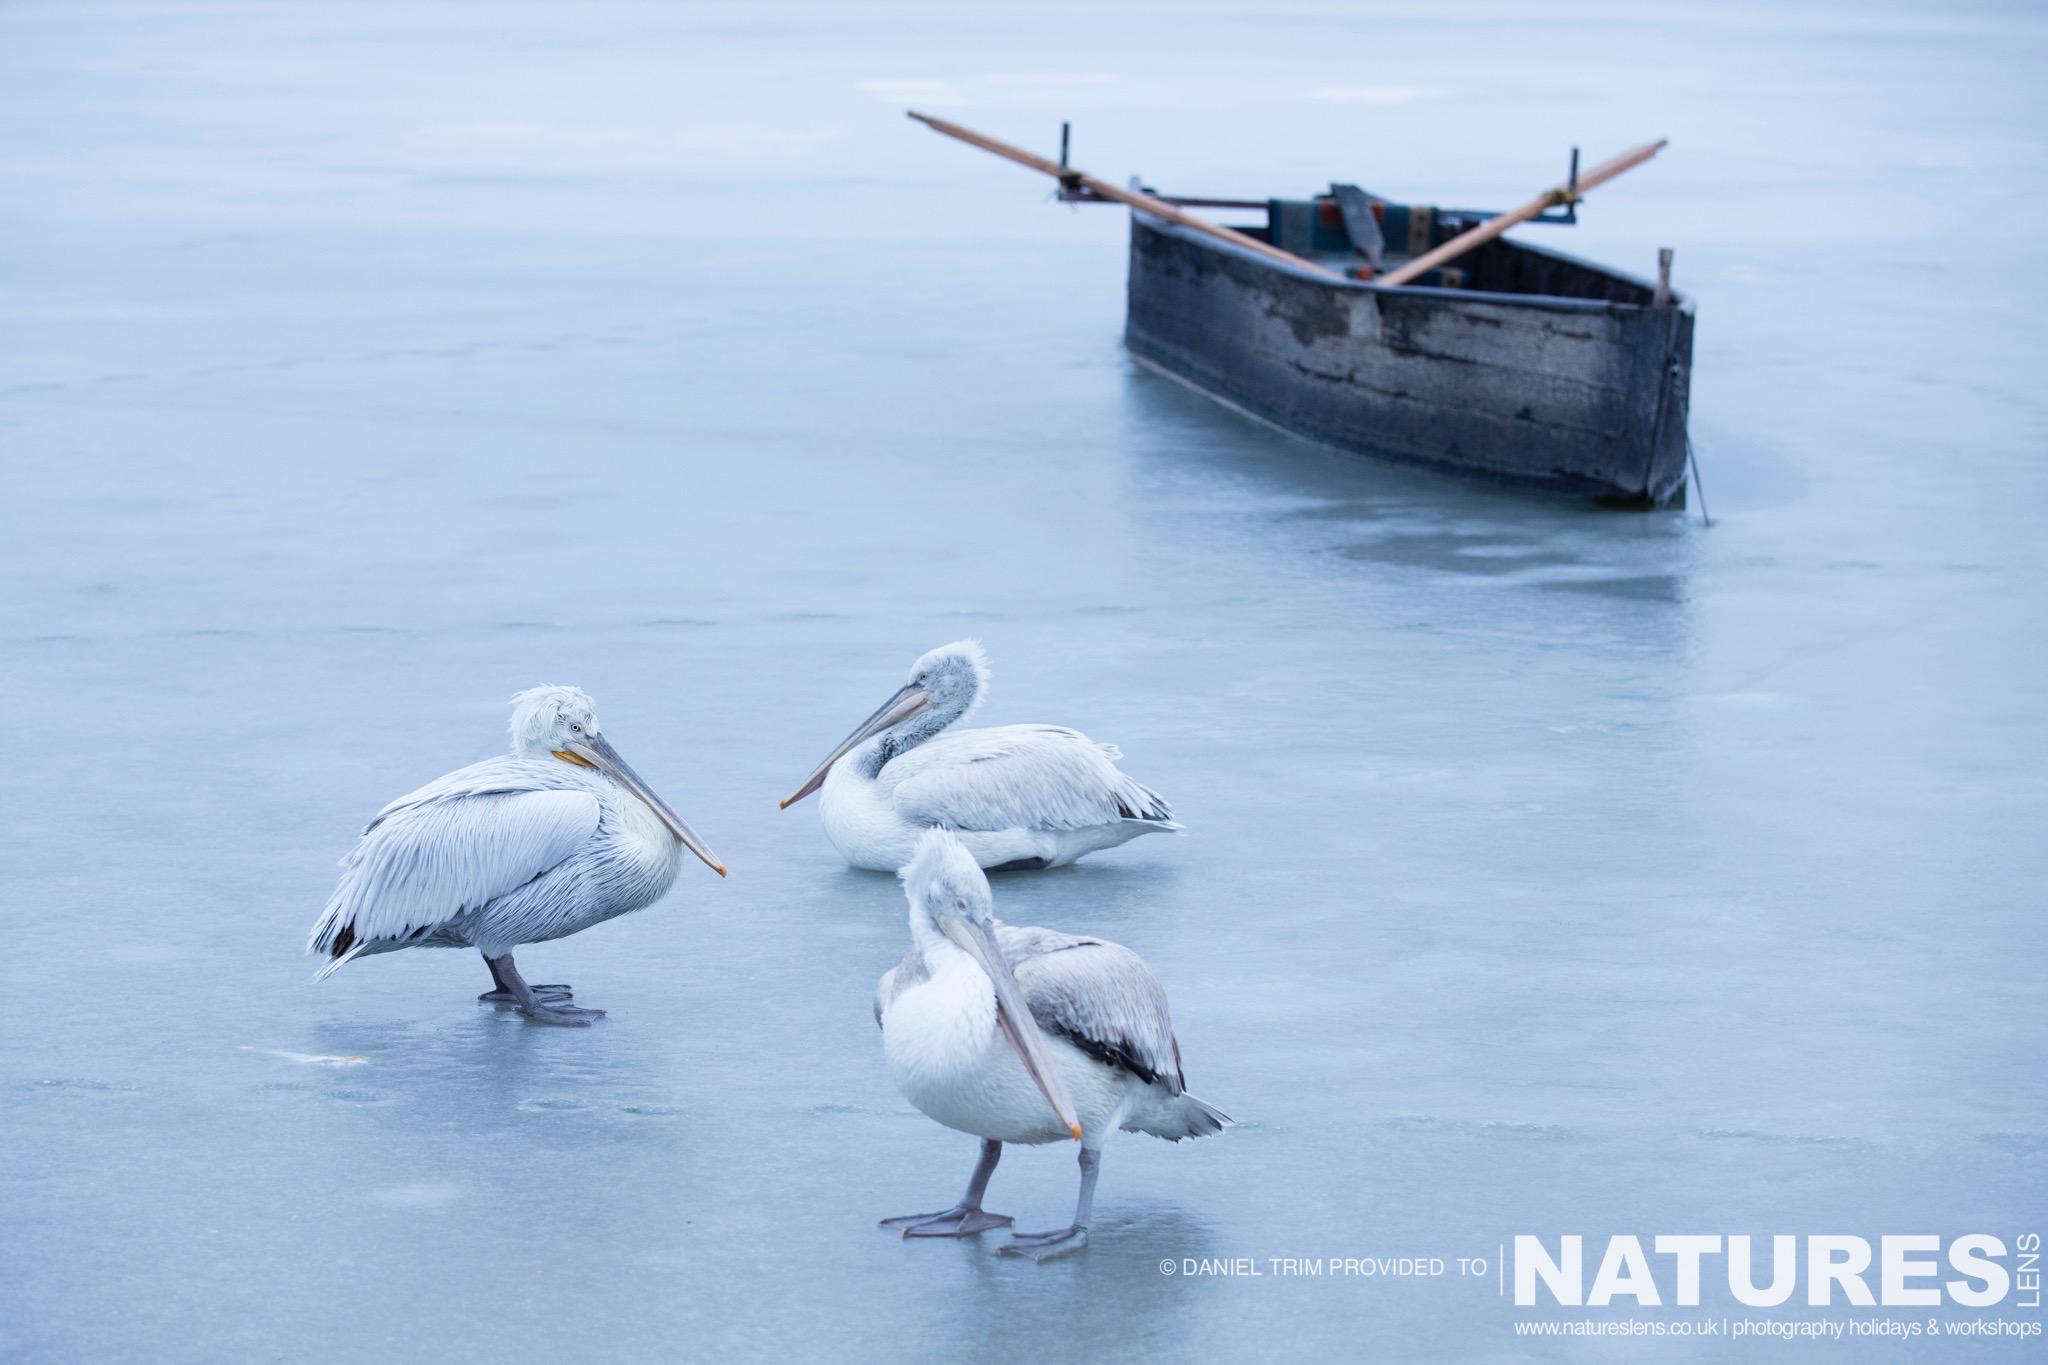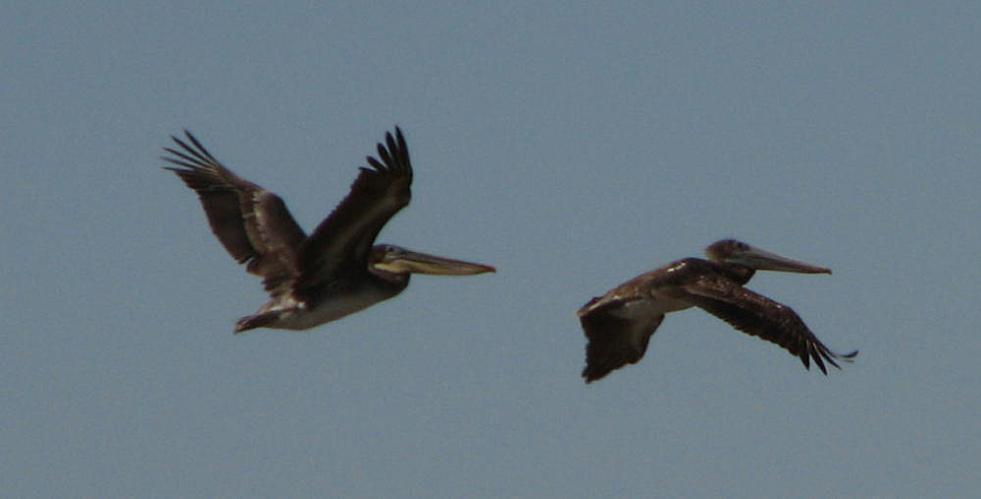The first image is the image on the left, the second image is the image on the right. Considering the images on both sides, is "The right image contains exactly two birds flying in the sky." valid? Answer yes or no. Yes. The first image is the image on the left, the second image is the image on the right. Examine the images to the left and right. Is the description "All pelicans are in flight, left and right images contain the same number of pelican-type birds, and no single image contains more than two pelicans." accurate? Answer yes or no. No. 